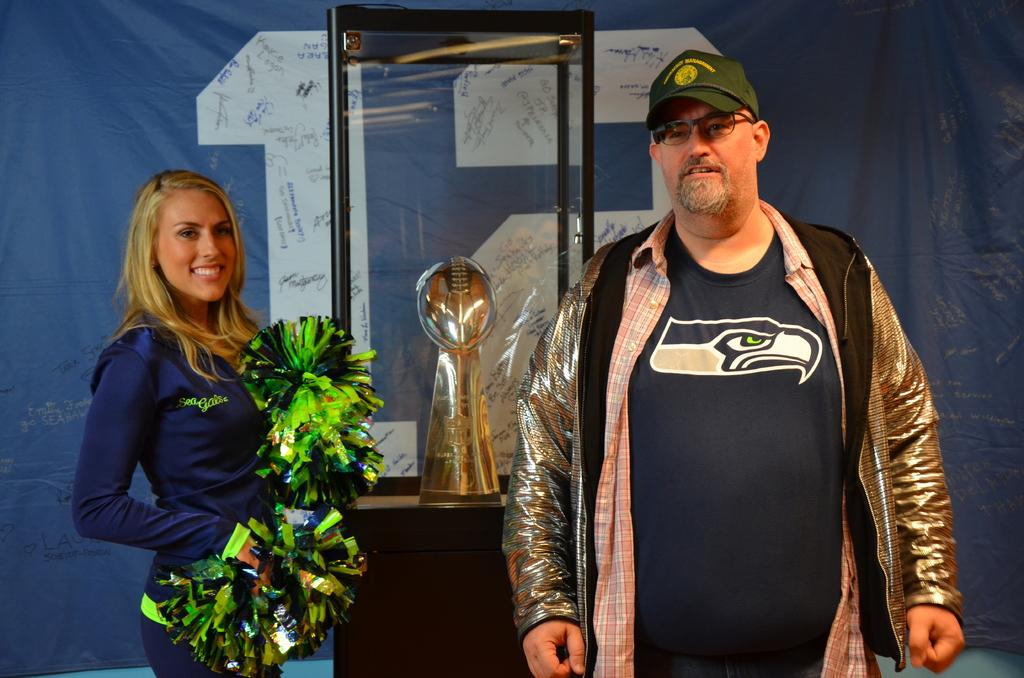How many people are in the image? There is a woman and a man in the image. Where are the woman and man located in the image? The woman and man are standing in the middle of the image. What can be seen in the background of the image? There is a glass box and a banner in the background of the image. What type of winter clothing is the man wearing in the image? There is no mention of winter clothing or any specific season in the image, as it only shows a woman and a man standing in the middle of the image with a glass box and a banner in the background. 